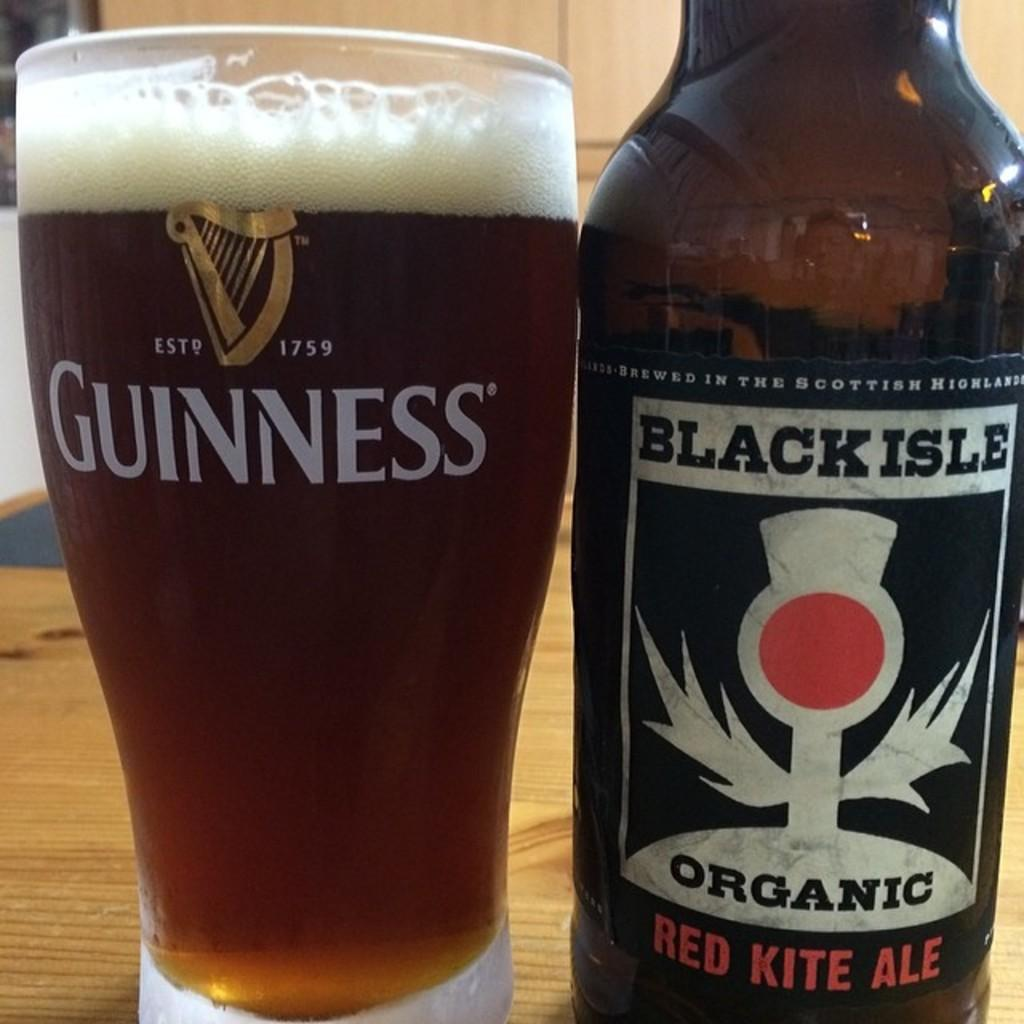What is present on the table in the image? There is a bottle and a glass with a drink in it on the table in the image. What is the bottle likely containing? The bottle's contents are not visible, so it cannot be determined what it contains. Can you describe the glass with a drink in it? The glass contains a drink, but the type of drink is not specified. Is there a goat in the image? No, there is no goat present in the image. What type of animal can be seen interacting with the bottle and glass in the image? There are no animals present in the image; it only features a bottle and a glass with a drink in it on a table. 